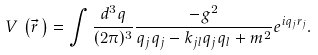Convert formula to latex. <formula><loc_0><loc_0><loc_500><loc_500>V \, \left ( \vec { r } \, \right ) = \int \frac { d ^ { 3 } q } { ( 2 \pi ) ^ { 3 } } \frac { - g ^ { 2 } } { q _ { j } q _ { j } - k _ { j l } q _ { j } q _ { l } + m ^ { 2 } } e ^ { i q _ { j } r _ { j } } .</formula> 